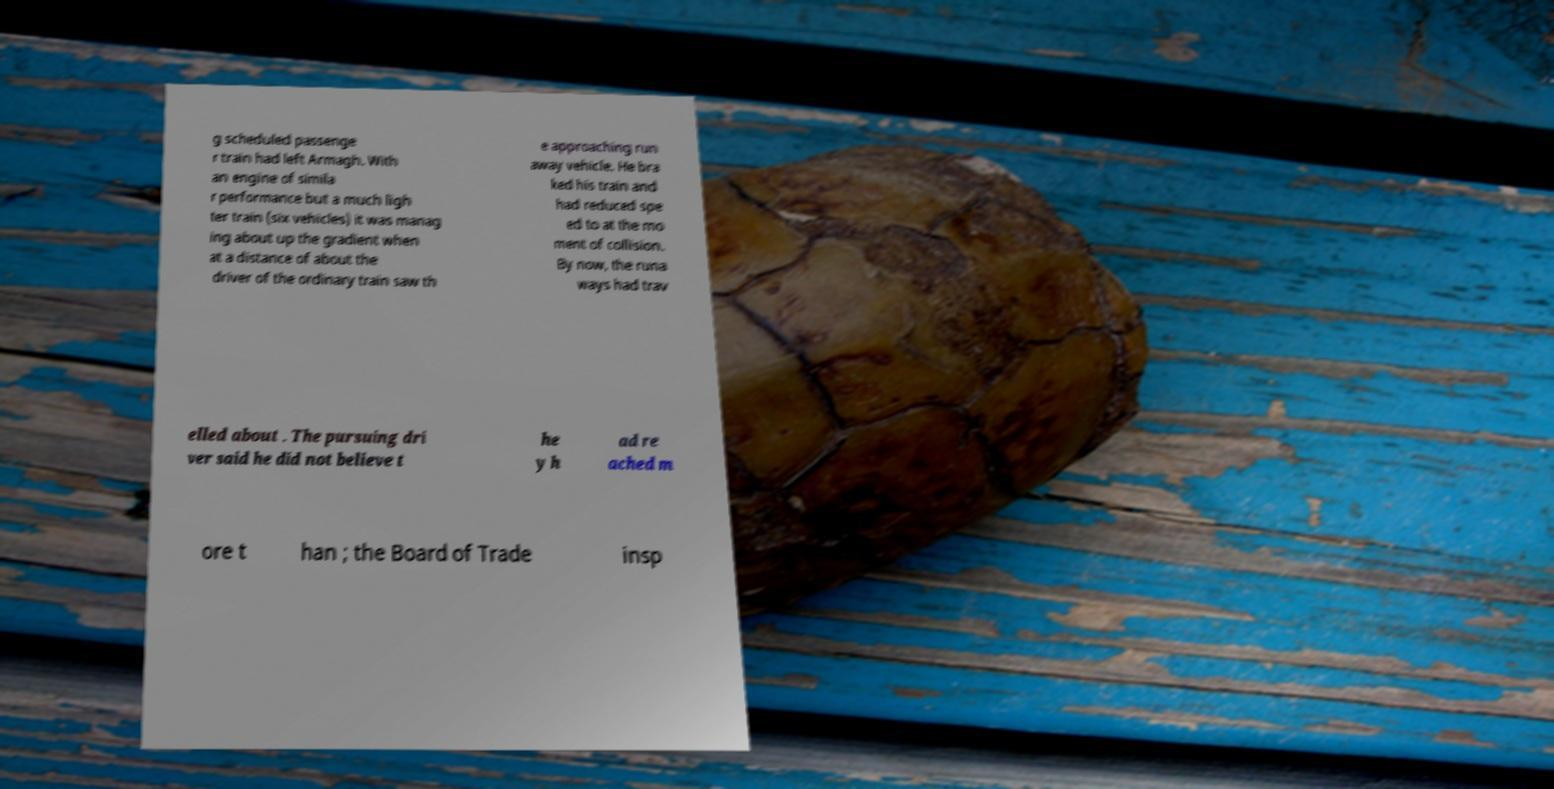I need the written content from this picture converted into text. Can you do that? g scheduled passenge r train had left Armagh. With an engine of simila r performance but a much ligh ter train (six vehicles) it was manag ing about up the gradient when at a distance of about the driver of the ordinary train saw th e approaching run away vehicle. He bra ked his train and had reduced spe ed to at the mo ment of collision. By now, the runa ways had trav elled about . The pursuing dri ver said he did not believe t he y h ad re ached m ore t han ; the Board of Trade insp 